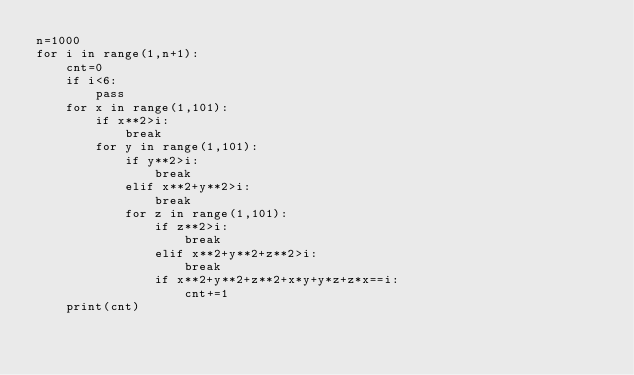Convert code to text. <code><loc_0><loc_0><loc_500><loc_500><_Python_>n=1000
for i in range(1,n+1):
    cnt=0
    if i<6:
        pass
    for x in range(1,101):
        if x**2>i:
            break
        for y in range(1,101):
            if y**2>i:
                break
            elif x**2+y**2>i:
                break
            for z in range(1,101):
                if z**2>i:
                    break
                elif x**2+y**2+z**2>i:
                    break
                if x**2+y**2+z**2+x*y+y*z+z*x==i:
                    cnt+=1
    print(cnt)</code> 